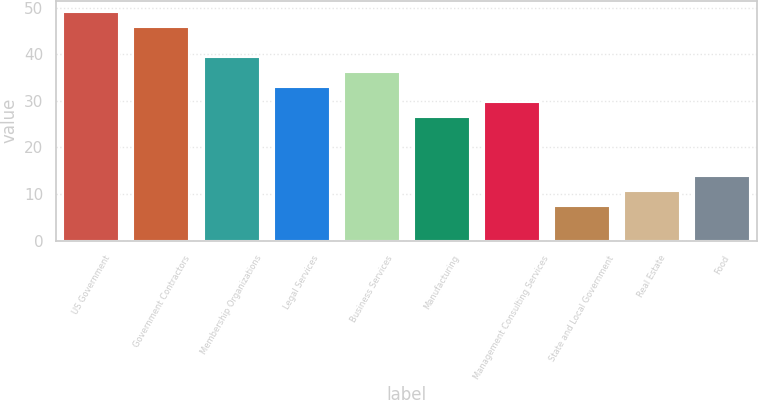Convert chart. <chart><loc_0><loc_0><loc_500><loc_500><bar_chart><fcel>US Government<fcel>Government Contractors<fcel>Membership Organizations<fcel>Legal Services<fcel>Business Services<fcel>Manufacturing<fcel>Management Consulting Services<fcel>State and Local Government<fcel>Real Estate<fcel>Food<nl><fcel>49<fcel>45.8<fcel>39.4<fcel>33<fcel>36.2<fcel>26.6<fcel>29.8<fcel>7.4<fcel>10.6<fcel>13.8<nl></chart> 